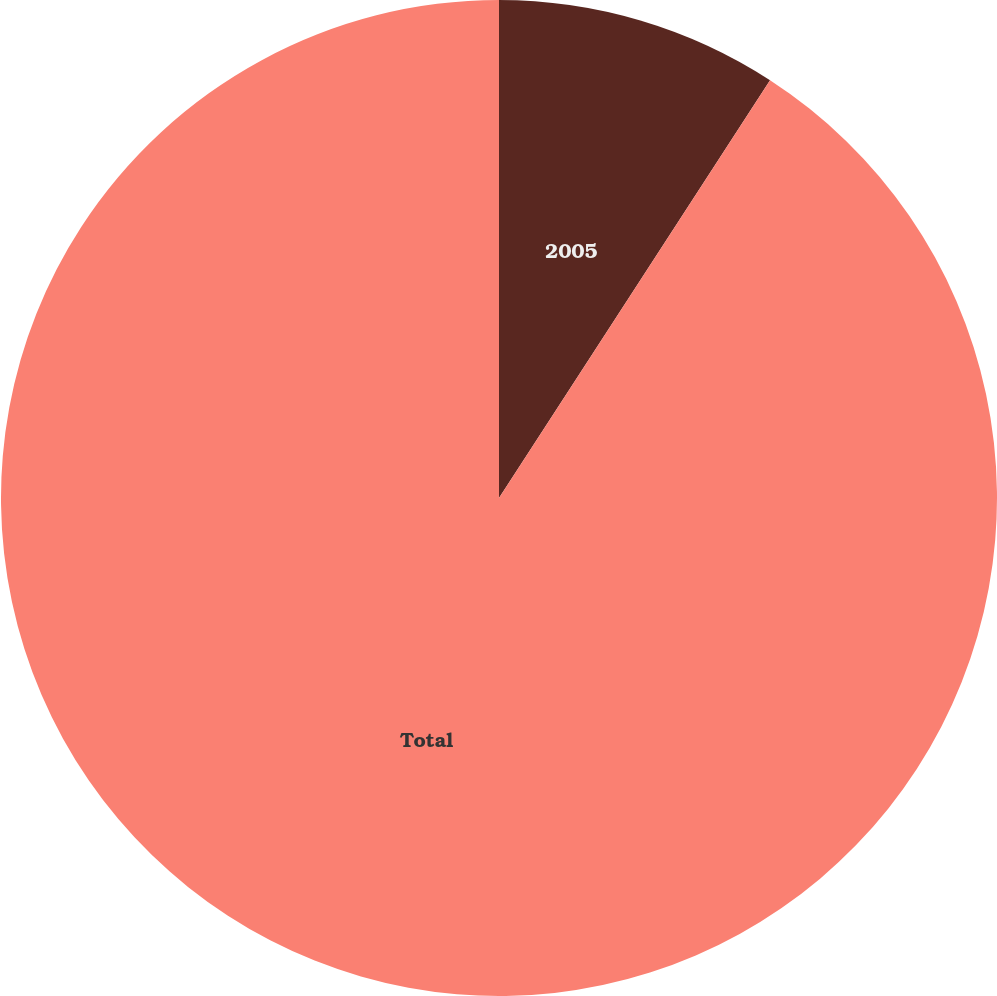<chart> <loc_0><loc_0><loc_500><loc_500><pie_chart><fcel>2005<fcel>Total<nl><fcel>9.16%<fcel>90.84%<nl></chart> 